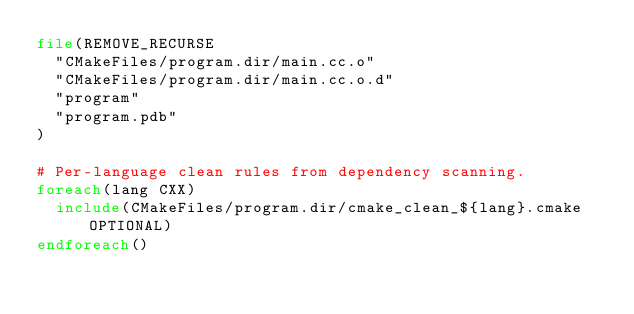<code> <loc_0><loc_0><loc_500><loc_500><_CMake_>file(REMOVE_RECURSE
  "CMakeFiles/program.dir/main.cc.o"
  "CMakeFiles/program.dir/main.cc.o.d"
  "program"
  "program.pdb"
)

# Per-language clean rules from dependency scanning.
foreach(lang CXX)
  include(CMakeFiles/program.dir/cmake_clean_${lang}.cmake OPTIONAL)
endforeach()
</code> 